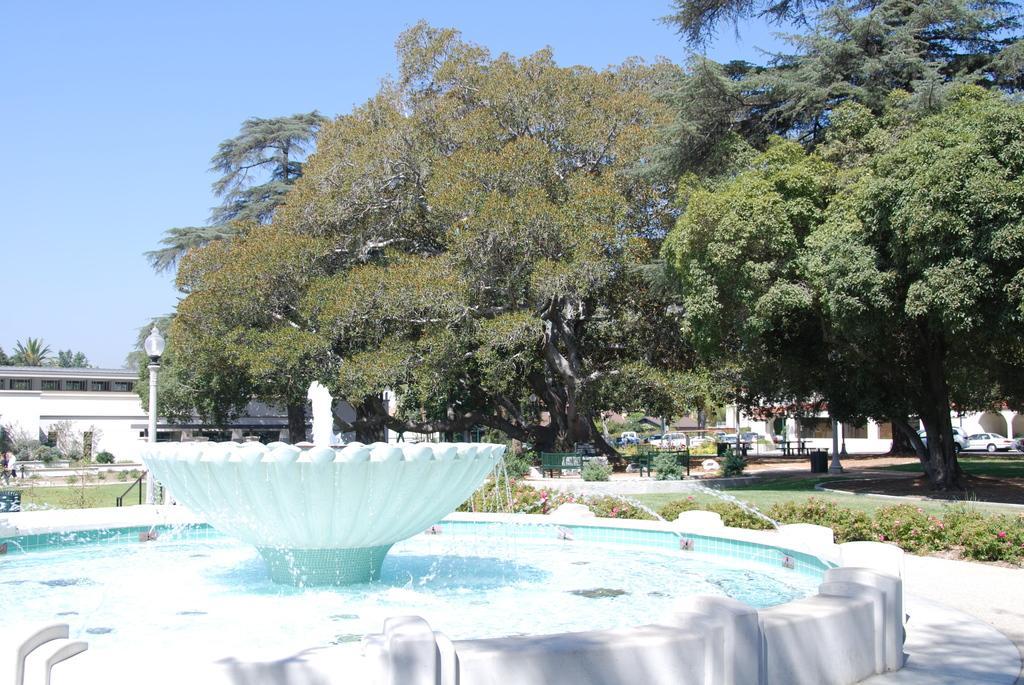Describe this image in one or two sentences. In this image we can see fountains. In the back there are trees. Also there are plants with flowers. And there is a light pole. In the background there are buildings, benches and vehicles. And there is sky. 